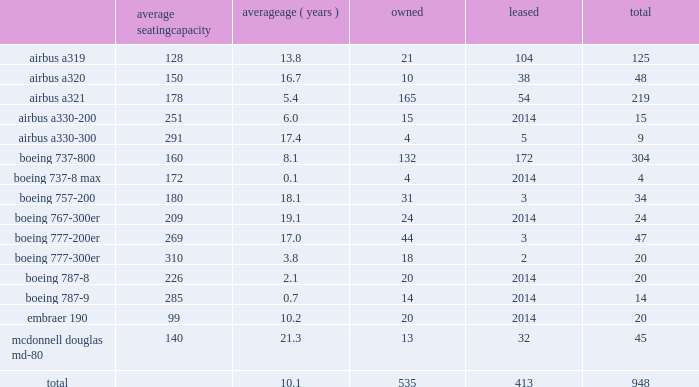Item 2 .
Properties flight equipment and fleet renewal as of december 31 , 2017 , american operated a mainline fleet of 948 aircraft .
In 2017 , we continued our extensive fleet renewal program , which has provided us with the youngest fleet of the major u.s .
Network carriers .
During 2017 , american took delivery of 57 new mainline aircraft and retired 39 mainline aircraft .
We are supported by our wholly-owned and third-party regional carriers that fly under capacity purchase agreements operating as american eagle .
As of december 31 , 2017 , american eagle operated 597 regional aircraft .
During 2017 , we reduced our regional fleet by a net of nine aircraft , including the addition of 63 regional aircraft and retirement of 72 regional aircraft .
Mainline as of december 31 , 2017 , american 2019s mainline fleet consisted of the following aircraft : average seating capacity average ( years ) owned leased total .

Did american have access to more planes than american eagle at 12/31/17? 
Computations: (948 > 597)
Answer: yes. 